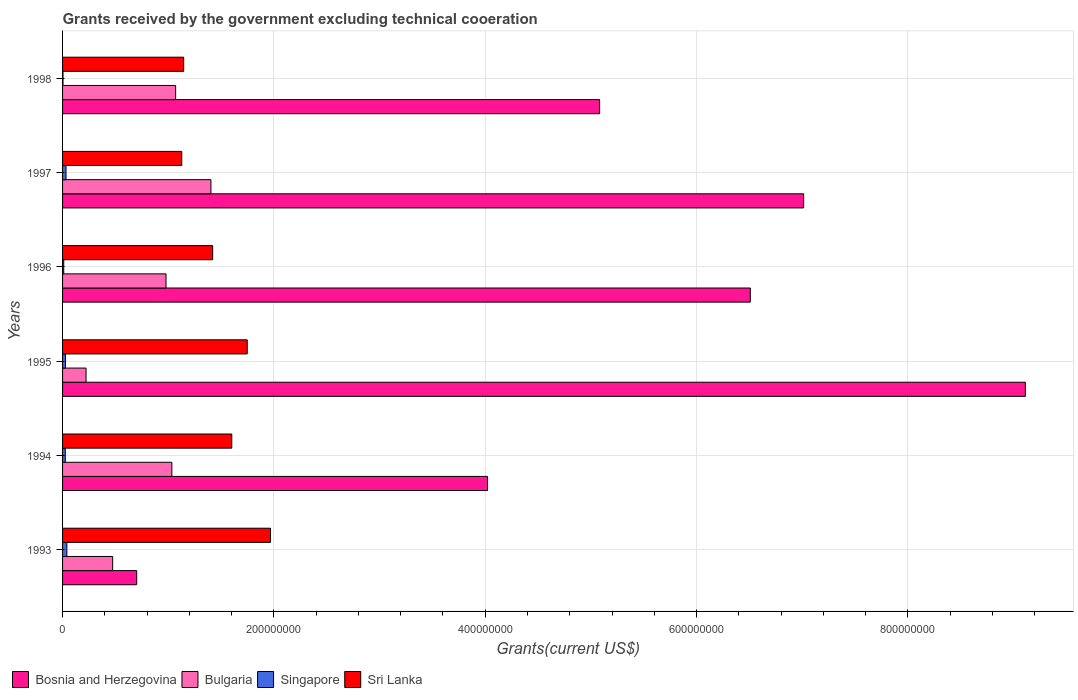How many different coloured bars are there?
Give a very brief answer. 4. How many groups of bars are there?
Provide a succinct answer. 6. Are the number of bars on each tick of the Y-axis equal?
Offer a terse response. Yes. How many bars are there on the 6th tick from the top?
Offer a very short reply. 4. What is the total grants received by the government in Singapore in 1993?
Provide a short and direct response. 4.07e+06. Across all years, what is the maximum total grants received by the government in Bosnia and Herzegovina?
Give a very brief answer. 9.11e+08. Across all years, what is the minimum total grants received by the government in Bosnia and Herzegovina?
Give a very brief answer. 7.02e+07. In which year was the total grants received by the government in Bosnia and Herzegovina maximum?
Your response must be concise. 1995. In which year was the total grants received by the government in Bosnia and Herzegovina minimum?
Provide a short and direct response. 1993. What is the total total grants received by the government in Bulgaria in the graph?
Provide a short and direct response. 5.18e+08. What is the difference between the total grants received by the government in Sri Lanka in 1997 and that in 1998?
Offer a terse response. -1.80e+06. What is the difference between the total grants received by the government in Bosnia and Herzegovina in 1996 and the total grants received by the government in Singapore in 1995?
Your answer should be very brief. 6.48e+08. What is the average total grants received by the government in Singapore per year?
Your answer should be very brief. 2.36e+06. In the year 1997, what is the difference between the total grants received by the government in Singapore and total grants received by the government in Bulgaria?
Give a very brief answer. -1.37e+08. What is the ratio of the total grants received by the government in Bosnia and Herzegovina in 1996 to that in 1998?
Your response must be concise. 1.28. Is the total grants received by the government in Bosnia and Herzegovina in 1995 less than that in 1998?
Your answer should be very brief. No. What is the difference between the highest and the second highest total grants received by the government in Bosnia and Herzegovina?
Offer a terse response. 2.10e+08. What is the difference between the highest and the lowest total grants received by the government in Bulgaria?
Make the answer very short. 1.18e+08. In how many years, is the total grants received by the government in Singapore greater than the average total grants received by the government in Singapore taken over all years?
Keep it short and to the point. 4. Is it the case that in every year, the sum of the total grants received by the government in Singapore and total grants received by the government in Bosnia and Herzegovina is greater than the sum of total grants received by the government in Bulgaria and total grants received by the government in Sri Lanka?
Offer a terse response. Yes. What does the 3rd bar from the bottom in 1994 represents?
Your answer should be compact. Singapore. How many bars are there?
Your answer should be compact. 24. How many years are there in the graph?
Ensure brevity in your answer.  6. Are the values on the major ticks of X-axis written in scientific E-notation?
Provide a short and direct response. No. Where does the legend appear in the graph?
Give a very brief answer. Bottom left. How many legend labels are there?
Your answer should be compact. 4. How are the legend labels stacked?
Make the answer very short. Horizontal. What is the title of the graph?
Your answer should be compact. Grants received by the government excluding technical cooeration. Does "High income" appear as one of the legend labels in the graph?
Keep it short and to the point. No. What is the label or title of the X-axis?
Your response must be concise. Grants(current US$). What is the label or title of the Y-axis?
Provide a short and direct response. Years. What is the Grants(current US$) in Bosnia and Herzegovina in 1993?
Ensure brevity in your answer.  7.02e+07. What is the Grants(current US$) of Bulgaria in 1993?
Keep it short and to the point. 4.74e+07. What is the Grants(current US$) of Singapore in 1993?
Your answer should be compact. 4.07e+06. What is the Grants(current US$) in Sri Lanka in 1993?
Give a very brief answer. 1.97e+08. What is the Grants(current US$) of Bosnia and Herzegovina in 1994?
Provide a short and direct response. 4.02e+08. What is the Grants(current US$) of Bulgaria in 1994?
Give a very brief answer. 1.03e+08. What is the Grants(current US$) in Singapore in 1994?
Your answer should be very brief. 2.57e+06. What is the Grants(current US$) in Sri Lanka in 1994?
Provide a succinct answer. 1.60e+08. What is the Grants(current US$) of Bosnia and Herzegovina in 1995?
Your answer should be very brief. 9.11e+08. What is the Grants(current US$) in Bulgaria in 1995?
Your response must be concise. 2.22e+07. What is the Grants(current US$) of Singapore in 1995?
Give a very brief answer. 2.76e+06. What is the Grants(current US$) of Sri Lanka in 1995?
Ensure brevity in your answer.  1.75e+08. What is the Grants(current US$) of Bosnia and Herzegovina in 1996?
Make the answer very short. 6.51e+08. What is the Grants(current US$) in Bulgaria in 1996?
Keep it short and to the point. 9.79e+07. What is the Grants(current US$) in Singapore in 1996?
Provide a short and direct response. 1.11e+06. What is the Grants(current US$) of Sri Lanka in 1996?
Keep it short and to the point. 1.42e+08. What is the Grants(current US$) of Bosnia and Herzegovina in 1997?
Give a very brief answer. 7.01e+08. What is the Grants(current US$) of Bulgaria in 1997?
Offer a terse response. 1.40e+08. What is the Grants(current US$) in Singapore in 1997?
Provide a succinct answer. 3.26e+06. What is the Grants(current US$) of Sri Lanka in 1997?
Ensure brevity in your answer.  1.13e+08. What is the Grants(current US$) of Bosnia and Herzegovina in 1998?
Give a very brief answer. 5.08e+08. What is the Grants(current US$) of Bulgaria in 1998?
Offer a terse response. 1.07e+08. What is the Grants(current US$) of Singapore in 1998?
Ensure brevity in your answer.  4.20e+05. What is the Grants(current US$) of Sri Lanka in 1998?
Offer a very short reply. 1.15e+08. Across all years, what is the maximum Grants(current US$) in Bosnia and Herzegovina?
Offer a terse response. 9.11e+08. Across all years, what is the maximum Grants(current US$) of Bulgaria?
Keep it short and to the point. 1.40e+08. Across all years, what is the maximum Grants(current US$) of Singapore?
Give a very brief answer. 4.07e+06. Across all years, what is the maximum Grants(current US$) in Sri Lanka?
Your answer should be compact. 1.97e+08. Across all years, what is the minimum Grants(current US$) of Bosnia and Herzegovina?
Ensure brevity in your answer.  7.02e+07. Across all years, what is the minimum Grants(current US$) in Bulgaria?
Your answer should be compact. 2.22e+07. Across all years, what is the minimum Grants(current US$) in Sri Lanka?
Ensure brevity in your answer.  1.13e+08. What is the total Grants(current US$) in Bosnia and Herzegovina in the graph?
Your response must be concise. 3.24e+09. What is the total Grants(current US$) of Bulgaria in the graph?
Your answer should be very brief. 5.18e+08. What is the total Grants(current US$) in Singapore in the graph?
Provide a short and direct response. 1.42e+07. What is the total Grants(current US$) of Sri Lanka in the graph?
Your answer should be very brief. 9.01e+08. What is the difference between the Grants(current US$) of Bosnia and Herzegovina in 1993 and that in 1994?
Your response must be concise. -3.32e+08. What is the difference between the Grants(current US$) in Bulgaria in 1993 and that in 1994?
Your response must be concise. -5.60e+07. What is the difference between the Grants(current US$) of Singapore in 1993 and that in 1994?
Provide a short and direct response. 1.50e+06. What is the difference between the Grants(current US$) in Sri Lanka in 1993 and that in 1994?
Your response must be concise. 3.66e+07. What is the difference between the Grants(current US$) in Bosnia and Herzegovina in 1993 and that in 1995?
Give a very brief answer. -8.41e+08. What is the difference between the Grants(current US$) in Bulgaria in 1993 and that in 1995?
Provide a short and direct response. 2.52e+07. What is the difference between the Grants(current US$) in Singapore in 1993 and that in 1995?
Your response must be concise. 1.31e+06. What is the difference between the Grants(current US$) in Sri Lanka in 1993 and that in 1995?
Your answer should be compact. 2.20e+07. What is the difference between the Grants(current US$) in Bosnia and Herzegovina in 1993 and that in 1996?
Give a very brief answer. -5.81e+08. What is the difference between the Grants(current US$) of Bulgaria in 1993 and that in 1996?
Offer a terse response. -5.05e+07. What is the difference between the Grants(current US$) of Singapore in 1993 and that in 1996?
Provide a succinct answer. 2.96e+06. What is the difference between the Grants(current US$) of Sri Lanka in 1993 and that in 1996?
Make the answer very short. 5.47e+07. What is the difference between the Grants(current US$) of Bosnia and Herzegovina in 1993 and that in 1997?
Offer a terse response. -6.31e+08. What is the difference between the Grants(current US$) of Bulgaria in 1993 and that in 1997?
Ensure brevity in your answer.  -9.30e+07. What is the difference between the Grants(current US$) of Singapore in 1993 and that in 1997?
Offer a very short reply. 8.10e+05. What is the difference between the Grants(current US$) of Sri Lanka in 1993 and that in 1997?
Provide a short and direct response. 8.40e+07. What is the difference between the Grants(current US$) in Bosnia and Herzegovina in 1993 and that in 1998?
Your answer should be very brief. -4.38e+08. What is the difference between the Grants(current US$) of Bulgaria in 1993 and that in 1998?
Provide a short and direct response. -5.96e+07. What is the difference between the Grants(current US$) in Singapore in 1993 and that in 1998?
Provide a short and direct response. 3.65e+06. What is the difference between the Grants(current US$) in Sri Lanka in 1993 and that in 1998?
Keep it short and to the point. 8.22e+07. What is the difference between the Grants(current US$) of Bosnia and Herzegovina in 1994 and that in 1995?
Ensure brevity in your answer.  -5.09e+08. What is the difference between the Grants(current US$) in Bulgaria in 1994 and that in 1995?
Make the answer very short. 8.12e+07. What is the difference between the Grants(current US$) of Sri Lanka in 1994 and that in 1995?
Make the answer very short. -1.46e+07. What is the difference between the Grants(current US$) in Bosnia and Herzegovina in 1994 and that in 1996?
Ensure brevity in your answer.  -2.49e+08. What is the difference between the Grants(current US$) of Bulgaria in 1994 and that in 1996?
Provide a succinct answer. 5.52e+06. What is the difference between the Grants(current US$) in Singapore in 1994 and that in 1996?
Give a very brief answer. 1.46e+06. What is the difference between the Grants(current US$) in Sri Lanka in 1994 and that in 1996?
Your answer should be very brief. 1.81e+07. What is the difference between the Grants(current US$) in Bosnia and Herzegovina in 1994 and that in 1997?
Keep it short and to the point. -2.99e+08. What is the difference between the Grants(current US$) of Bulgaria in 1994 and that in 1997?
Provide a short and direct response. -3.70e+07. What is the difference between the Grants(current US$) in Singapore in 1994 and that in 1997?
Ensure brevity in your answer.  -6.90e+05. What is the difference between the Grants(current US$) in Sri Lanka in 1994 and that in 1997?
Keep it short and to the point. 4.73e+07. What is the difference between the Grants(current US$) in Bosnia and Herzegovina in 1994 and that in 1998?
Give a very brief answer. -1.06e+08. What is the difference between the Grants(current US$) in Bulgaria in 1994 and that in 1998?
Ensure brevity in your answer.  -3.58e+06. What is the difference between the Grants(current US$) of Singapore in 1994 and that in 1998?
Your answer should be very brief. 2.15e+06. What is the difference between the Grants(current US$) of Sri Lanka in 1994 and that in 1998?
Provide a succinct answer. 4.55e+07. What is the difference between the Grants(current US$) in Bosnia and Herzegovina in 1995 and that in 1996?
Offer a very short reply. 2.60e+08. What is the difference between the Grants(current US$) of Bulgaria in 1995 and that in 1996?
Make the answer very short. -7.57e+07. What is the difference between the Grants(current US$) of Singapore in 1995 and that in 1996?
Provide a short and direct response. 1.65e+06. What is the difference between the Grants(current US$) in Sri Lanka in 1995 and that in 1996?
Provide a succinct answer. 3.27e+07. What is the difference between the Grants(current US$) in Bosnia and Herzegovina in 1995 and that in 1997?
Provide a succinct answer. 2.10e+08. What is the difference between the Grants(current US$) in Bulgaria in 1995 and that in 1997?
Keep it short and to the point. -1.18e+08. What is the difference between the Grants(current US$) of Singapore in 1995 and that in 1997?
Make the answer very short. -5.00e+05. What is the difference between the Grants(current US$) of Sri Lanka in 1995 and that in 1997?
Keep it short and to the point. 6.19e+07. What is the difference between the Grants(current US$) of Bosnia and Herzegovina in 1995 and that in 1998?
Your answer should be very brief. 4.03e+08. What is the difference between the Grants(current US$) of Bulgaria in 1995 and that in 1998?
Ensure brevity in your answer.  -8.48e+07. What is the difference between the Grants(current US$) in Singapore in 1995 and that in 1998?
Offer a very short reply. 2.34e+06. What is the difference between the Grants(current US$) of Sri Lanka in 1995 and that in 1998?
Provide a short and direct response. 6.01e+07. What is the difference between the Grants(current US$) of Bosnia and Herzegovina in 1996 and that in 1997?
Make the answer very short. -5.05e+07. What is the difference between the Grants(current US$) of Bulgaria in 1996 and that in 1997?
Your response must be concise. -4.25e+07. What is the difference between the Grants(current US$) in Singapore in 1996 and that in 1997?
Your answer should be very brief. -2.15e+06. What is the difference between the Grants(current US$) of Sri Lanka in 1996 and that in 1997?
Your answer should be compact. 2.92e+07. What is the difference between the Grants(current US$) of Bosnia and Herzegovina in 1996 and that in 1998?
Provide a succinct answer. 1.43e+08. What is the difference between the Grants(current US$) of Bulgaria in 1996 and that in 1998?
Keep it short and to the point. -9.10e+06. What is the difference between the Grants(current US$) of Singapore in 1996 and that in 1998?
Provide a succinct answer. 6.90e+05. What is the difference between the Grants(current US$) of Sri Lanka in 1996 and that in 1998?
Make the answer very short. 2.74e+07. What is the difference between the Grants(current US$) in Bosnia and Herzegovina in 1997 and that in 1998?
Offer a terse response. 1.93e+08. What is the difference between the Grants(current US$) in Bulgaria in 1997 and that in 1998?
Your response must be concise. 3.34e+07. What is the difference between the Grants(current US$) of Singapore in 1997 and that in 1998?
Your answer should be compact. 2.84e+06. What is the difference between the Grants(current US$) of Sri Lanka in 1997 and that in 1998?
Make the answer very short. -1.80e+06. What is the difference between the Grants(current US$) of Bosnia and Herzegovina in 1993 and the Grants(current US$) of Bulgaria in 1994?
Offer a terse response. -3.33e+07. What is the difference between the Grants(current US$) of Bosnia and Herzegovina in 1993 and the Grants(current US$) of Singapore in 1994?
Your answer should be compact. 6.76e+07. What is the difference between the Grants(current US$) of Bosnia and Herzegovina in 1993 and the Grants(current US$) of Sri Lanka in 1994?
Offer a very short reply. -9.00e+07. What is the difference between the Grants(current US$) in Bulgaria in 1993 and the Grants(current US$) in Singapore in 1994?
Ensure brevity in your answer.  4.48e+07. What is the difference between the Grants(current US$) in Bulgaria in 1993 and the Grants(current US$) in Sri Lanka in 1994?
Offer a very short reply. -1.13e+08. What is the difference between the Grants(current US$) of Singapore in 1993 and the Grants(current US$) of Sri Lanka in 1994?
Keep it short and to the point. -1.56e+08. What is the difference between the Grants(current US$) in Bosnia and Herzegovina in 1993 and the Grants(current US$) in Bulgaria in 1995?
Your answer should be compact. 4.79e+07. What is the difference between the Grants(current US$) in Bosnia and Herzegovina in 1993 and the Grants(current US$) in Singapore in 1995?
Provide a succinct answer. 6.74e+07. What is the difference between the Grants(current US$) in Bosnia and Herzegovina in 1993 and the Grants(current US$) in Sri Lanka in 1995?
Offer a terse response. -1.05e+08. What is the difference between the Grants(current US$) in Bulgaria in 1993 and the Grants(current US$) in Singapore in 1995?
Provide a succinct answer. 4.46e+07. What is the difference between the Grants(current US$) of Bulgaria in 1993 and the Grants(current US$) of Sri Lanka in 1995?
Offer a very short reply. -1.27e+08. What is the difference between the Grants(current US$) in Singapore in 1993 and the Grants(current US$) in Sri Lanka in 1995?
Provide a succinct answer. -1.71e+08. What is the difference between the Grants(current US$) in Bosnia and Herzegovina in 1993 and the Grants(current US$) in Bulgaria in 1996?
Your response must be concise. -2.78e+07. What is the difference between the Grants(current US$) of Bosnia and Herzegovina in 1993 and the Grants(current US$) of Singapore in 1996?
Provide a short and direct response. 6.90e+07. What is the difference between the Grants(current US$) in Bosnia and Herzegovina in 1993 and the Grants(current US$) in Sri Lanka in 1996?
Your answer should be very brief. -7.19e+07. What is the difference between the Grants(current US$) in Bulgaria in 1993 and the Grants(current US$) in Singapore in 1996?
Provide a short and direct response. 4.63e+07. What is the difference between the Grants(current US$) of Bulgaria in 1993 and the Grants(current US$) of Sri Lanka in 1996?
Provide a short and direct response. -9.46e+07. What is the difference between the Grants(current US$) in Singapore in 1993 and the Grants(current US$) in Sri Lanka in 1996?
Provide a short and direct response. -1.38e+08. What is the difference between the Grants(current US$) in Bosnia and Herzegovina in 1993 and the Grants(current US$) in Bulgaria in 1997?
Ensure brevity in your answer.  -7.02e+07. What is the difference between the Grants(current US$) in Bosnia and Herzegovina in 1993 and the Grants(current US$) in Singapore in 1997?
Your answer should be compact. 6.69e+07. What is the difference between the Grants(current US$) of Bosnia and Herzegovina in 1993 and the Grants(current US$) of Sri Lanka in 1997?
Offer a terse response. -4.27e+07. What is the difference between the Grants(current US$) in Bulgaria in 1993 and the Grants(current US$) in Singapore in 1997?
Ensure brevity in your answer.  4.41e+07. What is the difference between the Grants(current US$) of Bulgaria in 1993 and the Grants(current US$) of Sri Lanka in 1997?
Give a very brief answer. -6.54e+07. What is the difference between the Grants(current US$) in Singapore in 1993 and the Grants(current US$) in Sri Lanka in 1997?
Give a very brief answer. -1.09e+08. What is the difference between the Grants(current US$) in Bosnia and Herzegovina in 1993 and the Grants(current US$) in Bulgaria in 1998?
Ensure brevity in your answer.  -3.69e+07. What is the difference between the Grants(current US$) of Bosnia and Herzegovina in 1993 and the Grants(current US$) of Singapore in 1998?
Make the answer very short. 6.97e+07. What is the difference between the Grants(current US$) of Bosnia and Herzegovina in 1993 and the Grants(current US$) of Sri Lanka in 1998?
Keep it short and to the point. -4.45e+07. What is the difference between the Grants(current US$) in Bulgaria in 1993 and the Grants(current US$) in Singapore in 1998?
Offer a very short reply. 4.70e+07. What is the difference between the Grants(current US$) of Bulgaria in 1993 and the Grants(current US$) of Sri Lanka in 1998?
Your answer should be compact. -6.72e+07. What is the difference between the Grants(current US$) in Singapore in 1993 and the Grants(current US$) in Sri Lanka in 1998?
Your answer should be very brief. -1.11e+08. What is the difference between the Grants(current US$) in Bosnia and Herzegovina in 1994 and the Grants(current US$) in Bulgaria in 1995?
Your answer should be very brief. 3.80e+08. What is the difference between the Grants(current US$) of Bosnia and Herzegovina in 1994 and the Grants(current US$) of Singapore in 1995?
Keep it short and to the point. 3.99e+08. What is the difference between the Grants(current US$) in Bosnia and Herzegovina in 1994 and the Grants(current US$) in Sri Lanka in 1995?
Provide a succinct answer. 2.27e+08. What is the difference between the Grants(current US$) in Bulgaria in 1994 and the Grants(current US$) in Singapore in 1995?
Ensure brevity in your answer.  1.01e+08. What is the difference between the Grants(current US$) in Bulgaria in 1994 and the Grants(current US$) in Sri Lanka in 1995?
Your answer should be compact. -7.13e+07. What is the difference between the Grants(current US$) in Singapore in 1994 and the Grants(current US$) in Sri Lanka in 1995?
Provide a short and direct response. -1.72e+08. What is the difference between the Grants(current US$) of Bosnia and Herzegovina in 1994 and the Grants(current US$) of Bulgaria in 1996?
Provide a short and direct response. 3.04e+08. What is the difference between the Grants(current US$) in Bosnia and Herzegovina in 1994 and the Grants(current US$) in Singapore in 1996?
Provide a short and direct response. 4.01e+08. What is the difference between the Grants(current US$) of Bosnia and Herzegovina in 1994 and the Grants(current US$) of Sri Lanka in 1996?
Ensure brevity in your answer.  2.60e+08. What is the difference between the Grants(current US$) in Bulgaria in 1994 and the Grants(current US$) in Singapore in 1996?
Provide a short and direct response. 1.02e+08. What is the difference between the Grants(current US$) of Bulgaria in 1994 and the Grants(current US$) of Sri Lanka in 1996?
Your answer should be compact. -3.86e+07. What is the difference between the Grants(current US$) of Singapore in 1994 and the Grants(current US$) of Sri Lanka in 1996?
Keep it short and to the point. -1.39e+08. What is the difference between the Grants(current US$) in Bosnia and Herzegovina in 1994 and the Grants(current US$) in Bulgaria in 1997?
Provide a short and direct response. 2.62e+08. What is the difference between the Grants(current US$) of Bosnia and Herzegovina in 1994 and the Grants(current US$) of Singapore in 1997?
Give a very brief answer. 3.99e+08. What is the difference between the Grants(current US$) of Bosnia and Herzegovina in 1994 and the Grants(current US$) of Sri Lanka in 1997?
Give a very brief answer. 2.89e+08. What is the difference between the Grants(current US$) of Bulgaria in 1994 and the Grants(current US$) of Singapore in 1997?
Make the answer very short. 1.00e+08. What is the difference between the Grants(current US$) in Bulgaria in 1994 and the Grants(current US$) in Sri Lanka in 1997?
Provide a succinct answer. -9.38e+06. What is the difference between the Grants(current US$) of Singapore in 1994 and the Grants(current US$) of Sri Lanka in 1997?
Keep it short and to the point. -1.10e+08. What is the difference between the Grants(current US$) of Bosnia and Herzegovina in 1994 and the Grants(current US$) of Bulgaria in 1998?
Give a very brief answer. 2.95e+08. What is the difference between the Grants(current US$) of Bosnia and Herzegovina in 1994 and the Grants(current US$) of Singapore in 1998?
Offer a very short reply. 4.02e+08. What is the difference between the Grants(current US$) of Bosnia and Herzegovina in 1994 and the Grants(current US$) of Sri Lanka in 1998?
Your response must be concise. 2.88e+08. What is the difference between the Grants(current US$) of Bulgaria in 1994 and the Grants(current US$) of Singapore in 1998?
Make the answer very short. 1.03e+08. What is the difference between the Grants(current US$) in Bulgaria in 1994 and the Grants(current US$) in Sri Lanka in 1998?
Provide a succinct answer. -1.12e+07. What is the difference between the Grants(current US$) of Singapore in 1994 and the Grants(current US$) of Sri Lanka in 1998?
Your answer should be very brief. -1.12e+08. What is the difference between the Grants(current US$) in Bosnia and Herzegovina in 1995 and the Grants(current US$) in Bulgaria in 1996?
Keep it short and to the point. 8.13e+08. What is the difference between the Grants(current US$) in Bosnia and Herzegovina in 1995 and the Grants(current US$) in Singapore in 1996?
Keep it short and to the point. 9.10e+08. What is the difference between the Grants(current US$) in Bosnia and Herzegovina in 1995 and the Grants(current US$) in Sri Lanka in 1996?
Ensure brevity in your answer.  7.69e+08. What is the difference between the Grants(current US$) of Bulgaria in 1995 and the Grants(current US$) of Singapore in 1996?
Offer a very short reply. 2.11e+07. What is the difference between the Grants(current US$) in Bulgaria in 1995 and the Grants(current US$) in Sri Lanka in 1996?
Give a very brief answer. -1.20e+08. What is the difference between the Grants(current US$) in Singapore in 1995 and the Grants(current US$) in Sri Lanka in 1996?
Provide a short and direct response. -1.39e+08. What is the difference between the Grants(current US$) in Bosnia and Herzegovina in 1995 and the Grants(current US$) in Bulgaria in 1997?
Offer a terse response. 7.71e+08. What is the difference between the Grants(current US$) in Bosnia and Herzegovina in 1995 and the Grants(current US$) in Singapore in 1997?
Give a very brief answer. 9.08e+08. What is the difference between the Grants(current US$) in Bosnia and Herzegovina in 1995 and the Grants(current US$) in Sri Lanka in 1997?
Give a very brief answer. 7.98e+08. What is the difference between the Grants(current US$) in Bulgaria in 1995 and the Grants(current US$) in Singapore in 1997?
Give a very brief answer. 1.90e+07. What is the difference between the Grants(current US$) of Bulgaria in 1995 and the Grants(current US$) of Sri Lanka in 1997?
Ensure brevity in your answer.  -9.06e+07. What is the difference between the Grants(current US$) in Singapore in 1995 and the Grants(current US$) in Sri Lanka in 1997?
Offer a very short reply. -1.10e+08. What is the difference between the Grants(current US$) in Bosnia and Herzegovina in 1995 and the Grants(current US$) in Bulgaria in 1998?
Ensure brevity in your answer.  8.04e+08. What is the difference between the Grants(current US$) in Bosnia and Herzegovina in 1995 and the Grants(current US$) in Singapore in 1998?
Make the answer very short. 9.11e+08. What is the difference between the Grants(current US$) in Bosnia and Herzegovina in 1995 and the Grants(current US$) in Sri Lanka in 1998?
Offer a very short reply. 7.97e+08. What is the difference between the Grants(current US$) in Bulgaria in 1995 and the Grants(current US$) in Singapore in 1998?
Offer a terse response. 2.18e+07. What is the difference between the Grants(current US$) of Bulgaria in 1995 and the Grants(current US$) of Sri Lanka in 1998?
Give a very brief answer. -9.24e+07. What is the difference between the Grants(current US$) of Singapore in 1995 and the Grants(current US$) of Sri Lanka in 1998?
Offer a terse response. -1.12e+08. What is the difference between the Grants(current US$) in Bosnia and Herzegovina in 1996 and the Grants(current US$) in Bulgaria in 1997?
Your answer should be very brief. 5.10e+08. What is the difference between the Grants(current US$) of Bosnia and Herzegovina in 1996 and the Grants(current US$) of Singapore in 1997?
Offer a terse response. 6.48e+08. What is the difference between the Grants(current US$) in Bosnia and Herzegovina in 1996 and the Grants(current US$) in Sri Lanka in 1997?
Your response must be concise. 5.38e+08. What is the difference between the Grants(current US$) of Bulgaria in 1996 and the Grants(current US$) of Singapore in 1997?
Your answer should be very brief. 9.47e+07. What is the difference between the Grants(current US$) in Bulgaria in 1996 and the Grants(current US$) in Sri Lanka in 1997?
Give a very brief answer. -1.49e+07. What is the difference between the Grants(current US$) in Singapore in 1996 and the Grants(current US$) in Sri Lanka in 1997?
Keep it short and to the point. -1.12e+08. What is the difference between the Grants(current US$) in Bosnia and Herzegovina in 1996 and the Grants(current US$) in Bulgaria in 1998?
Give a very brief answer. 5.44e+08. What is the difference between the Grants(current US$) in Bosnia and Herzegovina in 1996 and the Grants(current US$) in Singapore in 1998?
Give a very brief answer. 6.50e+08. What is the difference between the Grants(current US$) in Bosnia and Herzegovina in 1996 and the Grants(current US$) in Sri Lanka in 1998?
Ensure brevity in your answer.  5.36e+08. What is the difference between the Grants(current US$) of Bulgaria in 1996 and the Grants(current US$) of Singapore in 1998?
Your answer should be compact. 9.75e+07. What is the difference between the Grants(current US$) of Bulgaria in 1996 and the Grants(current US$) of Sri Lanka in 1998?
Your answer should be very brief. -1.67e+07. What is the difference between the Grants(current US$) in Singapore in 1996 and the Grants(current US$) in Sri Lanka in 1998?
Offer a very short reply. -1.14e+08. What is the difference between the Grants(current US$) in Bosnia and Herzegovina in 1997 and the Grants(current US$) in Bulgaria in 1998?
Make the answer very short. 5.94e+08. What is the difference between the Grants(current US$) of Bosnia and Herzegovina in 1997 and the Grants(current US$) of Singapore in 1998?
Offer a terse response. 7.01e+08. What is the difference between the Grants(current US$) of Bosnia and Herzegovina in 1997 and the Grants(current US$) of Sri Lanka in 1998?
Offer a terse response. 5.87e+08. What is the difference between the Grants(current US$) of Bulgaria in 1997 and the Grants(current US$) of Singapore in 1998?
Make the answer very short. 1.40e+08. What is the difference between the Grants(current US$) in Bulgaria in 1997 and the Grants(current US$) in Sri Lanka in 1998?
Offer a terse response. 2.58e+07. What is the difference between the Grants(current US$) in Singapore in 1997 and the Grants(current US$) in Sri Lanka in 1998?
Your response must be concise. -1.11e+08. What is the average Grants(current US$) of Bosnia and Herzegovina per year?
Give a very brief answer. 5.41e+08. What is the average Grants(current US$) in Bulgaria per year?
Provide a succinct answer. 8.64e+07. What is the average Grants(current US$) of Singapore per year?
Your answer should be compact. 2.36e+06. What is the average Grants(current US$) of Sri Lanka per year?
Your response must be concise. 1.50e+08. In the year 1993, what is the difference between the Grants(current US$) of Bosnia and Herzegovina and Grants(current US$) of Bulgaria?
Keep it short and to the point. 2.28e+07. In the year 1993, what is the difference between the Grants(current US$) in Bosnia and Herzegovina and Grants(current US$) in Singapore?
Ensure brevity in your answer.  6.61e+07. In the year 1993, what is the difference between the Grants(current US$) of Bosnia and Herzegovina and Grants(current US$) of Sri Lanka?
Make the answer very short. -1.27e+08. In the year 1993, what is the difference between the Grants(current US$) in Bulgaria and Grants(current US$) in Singapore?
Give a very brief answer. 4.33e+07. In the year 1993, what is the difference between the Grants(current US$) in Bulgaria and Grants(current US$) in Sri Lanka?
Offer a very short reply. -1.49e+08. In the year 1993, what is the difference between the Grants(current US$) of Singapore and Grants(current US$) of Sri Lanka?
Provide a short and direct response. -1.93e+08. In the year 1994, what is the difference between the Grants(current US$) of Bosnia and Herzegovina and Grants(current US$) of Bulgaria?
Make the answer very short. 2.99e+08. In the year 1994, what is the difference between the Grants(current US$) of Bosnia and Herzegovina and Grants(current US$) of Singapore?
Offer a very short reply. 4.00e+08. In the year 1994, what is the difference between the Grants(current US$) of Bosnia and Herzegovina and Grants(current US$) of Sri Lanka?
Give a very brief answer. 2.42e+08. In the year 1994, what is the difference between the Grants(current US$) of Bulgaria and Grants(current US$) of Singapore?
Your answer should be compact. 1.01e+08. In the year 1994, what is the difference between the Grants(current US$) in Bulgaria and Grants(current US$) in Sri Lanka?
Provide a succinct answer. -5.67e+07. In the year 1994, what is the difference between the Grants(current US$) in Singapore and Grants(current US$) in Sri Lanka?
Provide a short and direct response. -1.58e+08. In the year 1995, what is the difference between the Grants(current US$) in Bosnia and Herzegovina and Grants(current US$) in Bulgaria?
Provide a succinct answer. 8.89e+08. In the year 1995, what is the difference between the Grants(current US$) of Bosnia and Herzegovina and Grants(current US$) of Singapore?
Your response must be concise. 9.08e+08. In the year 1995, what is the difference between the Grants(current US$) of Bosnia and Herzegovina and Grants(current US$) of Sri Lanka?
Your answer should be compact. 7.36e+08. In the year 1995, what is the difference between the Grants(current US$) in Bulgaria and Grants(current US$) in Singapore?
Your answer should be very brief. 1.95e+07. In the year 1995, what is the difference between the Grants(current US$) in Bulgaria and Grants(current US$) in Sri Lanka?
Give a very brief answer. -1.53e+08. In the year 1995, what is the difference between the Grants(current US$) in Singapore and Grants(current US$) in Sri Lanka?
Give a very brief answer. -1.72e+08. In the year 1996, what is the difference between the Grants(current US$) of Bosnia and Herzegovina and Grants(current US$) of Bulgaria?
Ensure brevity in your answer.  5.53e+08. In the year 1996, what is the difference between the Grants(current US$) in Bosnia and Herzegovina and Grants(current US$) in Singapore?
Make the answer very short. 6.50e+08. In the year 1996, what is the difference between the Grants(current US$) of Bosnia and Herzegovina and Grants(current US$) of Sri Lanka?
Make the answer very short. 5.09e+08. In the year 1996, what is the difference between the Grants(current US$) of Bulgaria and Grants(current US$) of Singapore?
Make the answer very short. 9.68e+07. In the year 1996, what is the difference between the Grants(current US$) of Bulgaria and Grants(current US$) of Sri Lanka?
Keep it short and to the point. -4.41e+07. In the year 1996, what is the difference between the Grants(current US$) of Singapore and Grants(current US$) of Sri Lanka?
Make the answer very short. -1.41e+08. In the year 1997, what is the difference between the Grants(current US$) of Bosnia and Herzegovina and Grants(current US$) of Bulgaria?
Ensure brevity in your answer.  5.61e+08. In the year 1997, what is the difference between the Grants(current US$) in Bosnia and Herzegovina and Grants(current US$) in Singapore?
Ensure brevity in your answer.  6.98e+08. In the year 1997, what is the difference between the Grants(current US$) in Bosnia and Herzegovina and Grants(current US$) in Sri Lanka?
Offer a terse response. 5.89e+08. In the year 1997, what is the difference between the Grants(current US$) of Bulgaria and Grants(current US$) of Singapore?
Make the answer very short. 1.37e+08. In the year 1997, what is the difference between the Grants(current US$) in Bulgaria and Grants(current US$) in Sri Lanka?
Keep it short and to the point. 2.76e+07. In the year 1997, what is the difference between the Grants(current US$) in Singapore and Grants(current US$) in Sri Lanka?
Ensure brevity in your answer.  -1.10e+08. In the year 1998, what is the difference between the Grants(current US$) of Bosnia and Herzegovina and Grants(current US$) of Bulgaria?
Provide a succinct answer. 4.01e+08. In the year 1998, what is the difference between the Grants(current US$) in Bosnia and Herzegovina and Grants(current US$) in Singapore?
Provide a short and direct response. 5.08e+08. In the year 1998, what is the difference between the Grants(current US$) in Bosnia and Herzegovina and Grants(current US$) in Sri Lanka?
Give a very brief answer. 3.94e+08. In the year 1998, what is the difference between the Grants(current US$) in Bulgaria and Grants(current US$) in Singapore?
Your answer should be very brief. 1.07e+08. In the year 1998, what is the difference between the Grants(current US$) in Bulgaria and Grants(current US$) in Sri Lanka?
Offer a terse response. -7.60e+06. In the year 1998, what is the difference between the Grants(current US$) of Singapore and Grants(current US$) of Sri Lanka?
Offer a terse response. -1.14e+08. What is the ratio of the Grants(current US$) of Bosnia and Herzegovina in 1993 to that in 1994?
Your answer should be compact. 0.17. What is the ratio of the Grants(current US$) in Bulgaria in 1993 to that in 1994?
Provide a short and direct response. 0.46. What is the ratio of the Grants(current US$) in Singapore in 1993 to that in 1994?
Keep it short and to the point. 1.58. What is the ratio of the Grants(current US$) of Sri Lanka in 1993 to that in 1994?
Offer a terse response. 1.23. What is the ratio of the Grants(current US$) in Bosnia and Herzegovina in 1993 to that in 1995?
Ensure brevity in your answer.  0.08. What is the ratio of the Grants(current US$) of Bulgaria in 1993 to that in 1995?
Provide a succinct answer. 2.13. What is the ratio of the Grants(current US$) of Singapore in 1993 to that in 1995?
Your answer should be very brief. 1.47. What is the ratio of the Grants(current US$) of Sri Lanka in 1993 to that in 1995?
Make the answer very short. 1.13. What is the ratio of the Grants(current US$) in Bosnia and Herzegovina in 1993 to that in 1996?
Make the answer very short. 0.11. What is the ratio of the Grants(current US$) of Bulgaria in 1993 to that in 1996?
Make the answer very short. 0.48. What is the ratio of the Grants(current US$) of Singapore in 1993 to that in 1996?
Keep it short and to the point. 3.67. What is the ratio of the Grants(current US$) of Sri Lanka in 1993 to that in 1996?
Provide a succinct answer. 1.39. What is the ratio of the Grants(current US$) in Bosnia and Herzegovina in 1993 to that in 1997?
Give a very brief answer. 0.1. What is the ratio of the Grants(current US$) in Bulgaria in 1993 to that in 1997?
Keep it short and to the point. 0.34. What is the ratio of the Grants(current US$) of Singapore in 1993 to that in 1997?
Provide a short and direct response. 1.25. What is the ratio of the Grants(current US$) of Sri Lanka in 1993 to that in 1997?
Your answer should be compact. 1.74. What is the ratio of the Grants(current US$) in Bosnia and Herzegovina in 1993 to that in 1998?
Your answer should be very brief. 0.14. What is the ratio of the Grants(current US$) of Bulgaria in 1993 to that in 1998?
Your answer should be compact. 0.44. What is the ratio of the Grants(current US$) of Singapore in 1993 to that in 1998?
Offer a terse response. 9.69. What is the ratio of the Grants(current US$) in Sri Lanka in 1993 to that in 1998?
Make the answer very short. 1.72. What is the ratio of the Grants(current US$) in Bosnia and Herzegovina in 1994 to that in 1995?
Offer a very short reply. 0.44. What is the ratio of the Grants(current US$) of Bulgaria in 1994 to that in 1995?
Your answer should be very brief. 4.65. What is the ratio of the Grants(current US$) in Singapore in 1994 to that in 1995?
Ensure brevity in your answer.  0.93. What is the ratio of the Grants(current US$) in Sri Lanka in 1994 to that in 1995?
Provide a succinct answer. 0.92. What is the ratio of the Grants(current US$) of Bosnia and Herzegovina in 1994 to that in 1996?
Make the answer very short. 0.62. What is the ratio of the Grants(current US$) in Bulgaria in 1994 to that in 1996?
Offer a terse response. 1.06. What is the ratio of the Grants(current US$) of Singapore in 1994 to that in 1996?
Offer a terse response. 2.32. What is the ratio of the Grants(current US$) of Sri Lanka in 1994 to that in 1996?
Offer a very short reply. 1.13. What is the ratio of the Grants(current US$) in Bosnia and Herzegovina in 1994 to that in 1997?
Offer a terse response. 0.57. What is the ratio of the Grants(current US$) in Bulgaria in 1994 to that in 1997?
Offer a very short reply. 0.74. What is the ratio of the Grants(current US$) of Singapore in 1994 to that in 1997?
Your response must be concise. 0.79. What is the ratio of the Grants(current US$) in Sri Lanka in 1994 to that in 1997?
Give a very brief answer. 1.42. What is the ratio of the Grants(current US$) of Bosnia and Herzegovina in 1994 to that in 1998?
Provide a short and direct response. 0.79. What is the ratio of the Grants(current US$) in Bulgaria in 1994 to that in 1998?
Your response must be concise. 0.97. What is the ratio of the Grants(current US$) of Singapore in 1994 to that in 1998?
Offer a terse response. 6.12. What is the ratio of the Grants(current US$) in Sri Lanka in 1994 to that in 1998?
Give a very brief answer. 1.4. What is the ratio of the Grants(current US$) in Bosnia and Herzegovina in 1995 to that in 1996?
Make the answer very short. 1.4. What is the ratio of the Grants(current US$) of Bulgaria in 1995 to that in 1996?
Keep it short and to the point. 0.23. What is the ratio of the Grants(current US$) of Singapore in 1995 to that in 1996?
Offer a very short reply. 2.49. What is the ratio of the Grants(current US$) in Sri Lanka in 1995 to that in 1996?
Your response must be concise. 1.23. What is the ratio of the Grants(current US$) of Bosnia and Herzegovina in 1995 to that in 1997?
Make the answer very short. 1.3. What is the ratio of the Grants(current US$) in Bulgaria in 1995 to that in 1997?
Provide a succinct answer. 0.16. What is the ratio of the Grants(current US$) in Singapore in 1995 to that in 1997?
Keep it short and to the point. 0.85. What is the ratio of the Grants(current US$) of Sri Lanka in 1995 to that in 1997?
Offer a terse response. 1.55. What is the ratio of the Grants(current US$) of Bosnia and Herzegovina in 1995 to that in 1998?
Offer a very short reply. 1.79. What is the ratio of the Grants(current US$) of Bulgaria in 1995 to that in 1998?
Provide a short and direct response. 0.21. What is the ratio of the Grants(current US$) of Singapore in 1995 to that in 1998?
Keep it short and to the point. 6.57. What is the ratio of the Grants(current US$) of Sri Lanka in 1995 to that in 1998?
Your answer should be compact. 1.52. What is the ratio of the Grants(current US$) in Bosnia and Herzegovina in 1996 to that in 1997?
Keep it short and to the point. 0.93. What is the ratio of the Grants(current US$) in Bulgaria in 1996 to that in 1997?
Keep it short and to the point. 0.7. What is the ratio of the Grants(current US$) in Singapore in 1996 to that in 1997?
Your answer should be very brief. 0.34. What is the ratio of the Grants(current US$) in Sri Lanka in 1996 to that in 1997?
Offer a terse response. 1.26. What is the ratio of the Grants(current US$) of Bosnia and Herzegovina in 1996 to that in 1998?
Offer a very short reply. 1.28. What is the ratio of the Grants(current US$) of Bulgaria in 1996 to that in 1998?
Provide a short and direct response. 0.92. What is the ratio of the Grants(current US$) in Singapore in 1996 to that in 1998?
Offer a terse response. 2.64. What is the ratio of the Grants(current US$) of Sri Lanka in 1996 to that in 1998?
Make the answer very short. 1.24. What is the ratio of the Grants(current US$) of Bosnia and Herzegovina in 1997 to that in 1998?
Provide a succinct answer. 1.38. What is the ratio of the Grants(current US$) of Bulgaria in 1997 to that in 1998?
Keep it short and to the point. 1.31. What is the ratio of the Grants(current US$) of Singapore in 1997 to that in 1998?
Provide a short and direct response. 7.76. What is the ratio of the Grants(current US$) in Sri Lanka in 1997 to that in 1998?
Your answer should be very brief. 0.98. What is the difference between the highest and the second highest Grants(current US$) in Bosnia and Herzegovina?
Make the answer very short. 2.10e+08. What is the difference between the highest and the second highest Grants(current US$) in Bulgaria?
Your response must be concise. 3.34e+07. What is the difference between the highest and the second highest Grants(current US$) in Singapore?
Offer a very short reply. 8.10e+05. What is the difference between the highest and the second highest Grants(current US$) of Sri Lanka?
Provide a succinct answer. 2.20e+07. What is the difference between the highest and the lowest Grants(current US$) in Bosnia and Herzegovina?
Your response must be concise. 8.41e+08. What is the difference between the highest and the lowest Grants(current US$) in Bulgaria?
Offer a very short reply. 1.18e+08. What is the difference between the highest and the lowest Grants(current US$) in Singapore?
Give a very brief answer. 3.65e+06. What is the difference between the highest and the lowest Grants(current US$) in Sri Lanka?
Offer a terse response. 8.40e+07. 